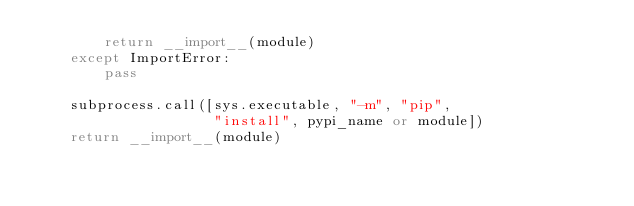<code> <loc_0><loc_0><loc_500><loc_500><_Python_>        return __import__(module)
    except ImportError:
        pass

    subprocess.call([sys.executable, "-m", "pip",
                     "install", pypi_name or module])
    return __import__(module)
</code> 